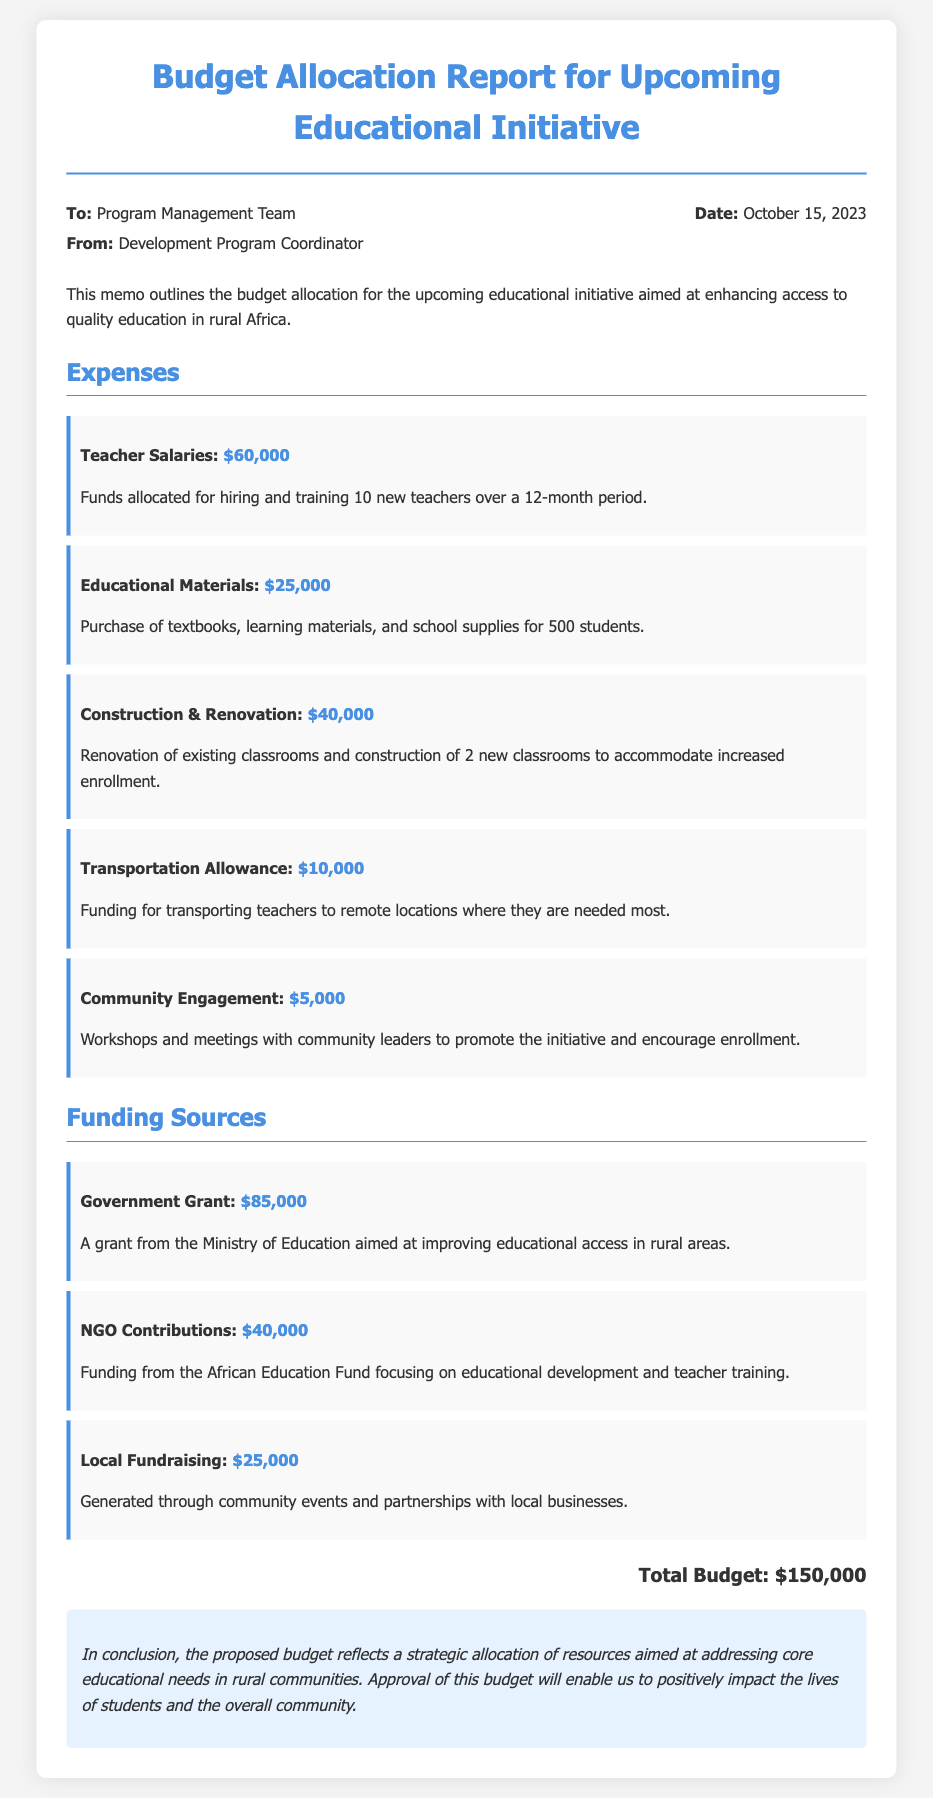What is the total budget? The total budget is explicitly stated at the end of the document as the cumulative sum of all expenses and funding sources.
Answer: $150,000 Who is the memo addressed to? The memo specifies the recipient in the upper section, indicating the program management team.
Answer: Program Management Team How much is allocated for teacher salaries? This information is found in the expenses section under teacher salaries.
Answer: $60,000 What is the amount of the government grant? The funding sources section specifies the amount of the government grant provided.
Answer: $85,000 What is the purpose of the community engagement fund? The memo specifies that community engagement funds are used for workshops and meetings with community leaders.
Answer: Promote the initiative Which organization contributes $40,000? The funding sources section mentions the contributing organization along with the amount.
Answer: African Education Fund How many new teachers are to be hired? The expenses section includes details of the new teachers to be hired under teacher salaries.
Answer: 10 What construction expenses are included? The expenses section specifies activities related to classrooms that are part of construction and renovation.
Answer: Renovation and construction What is the date of the memo? The date is clearly stated in the metadata section of the memo.
Answer: October 15, 2023 